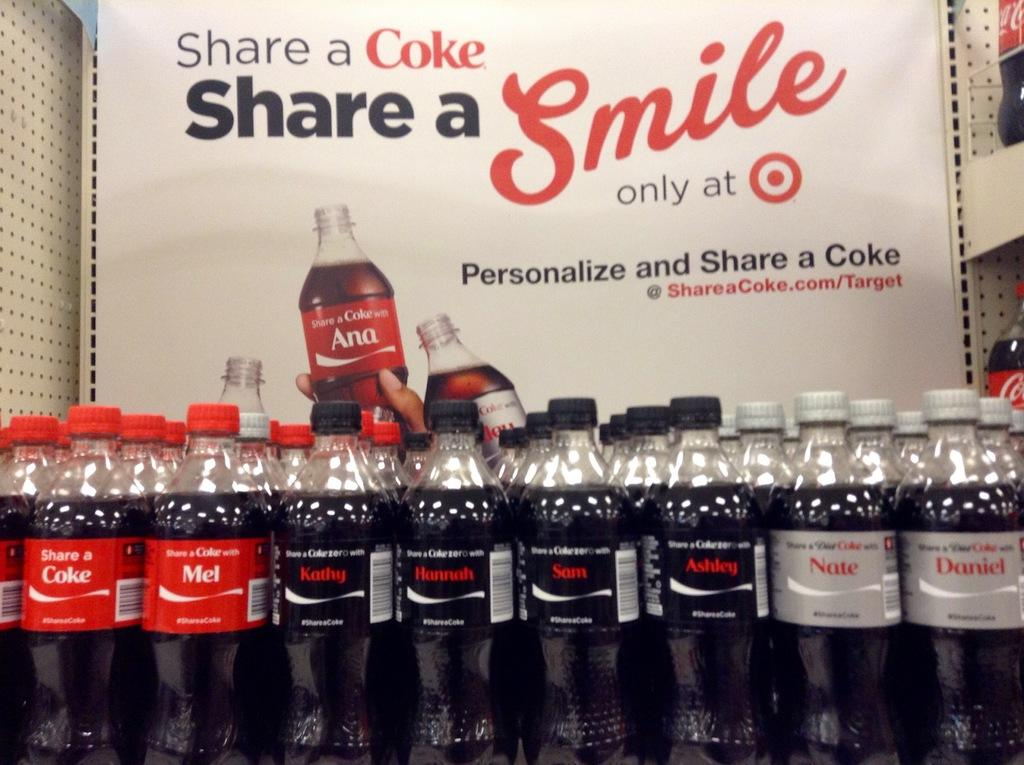<image>
Present a compact description of the photo's key features. A display of rows Coke products with a sign behind the display saying Share a Coke Share a Smile. 